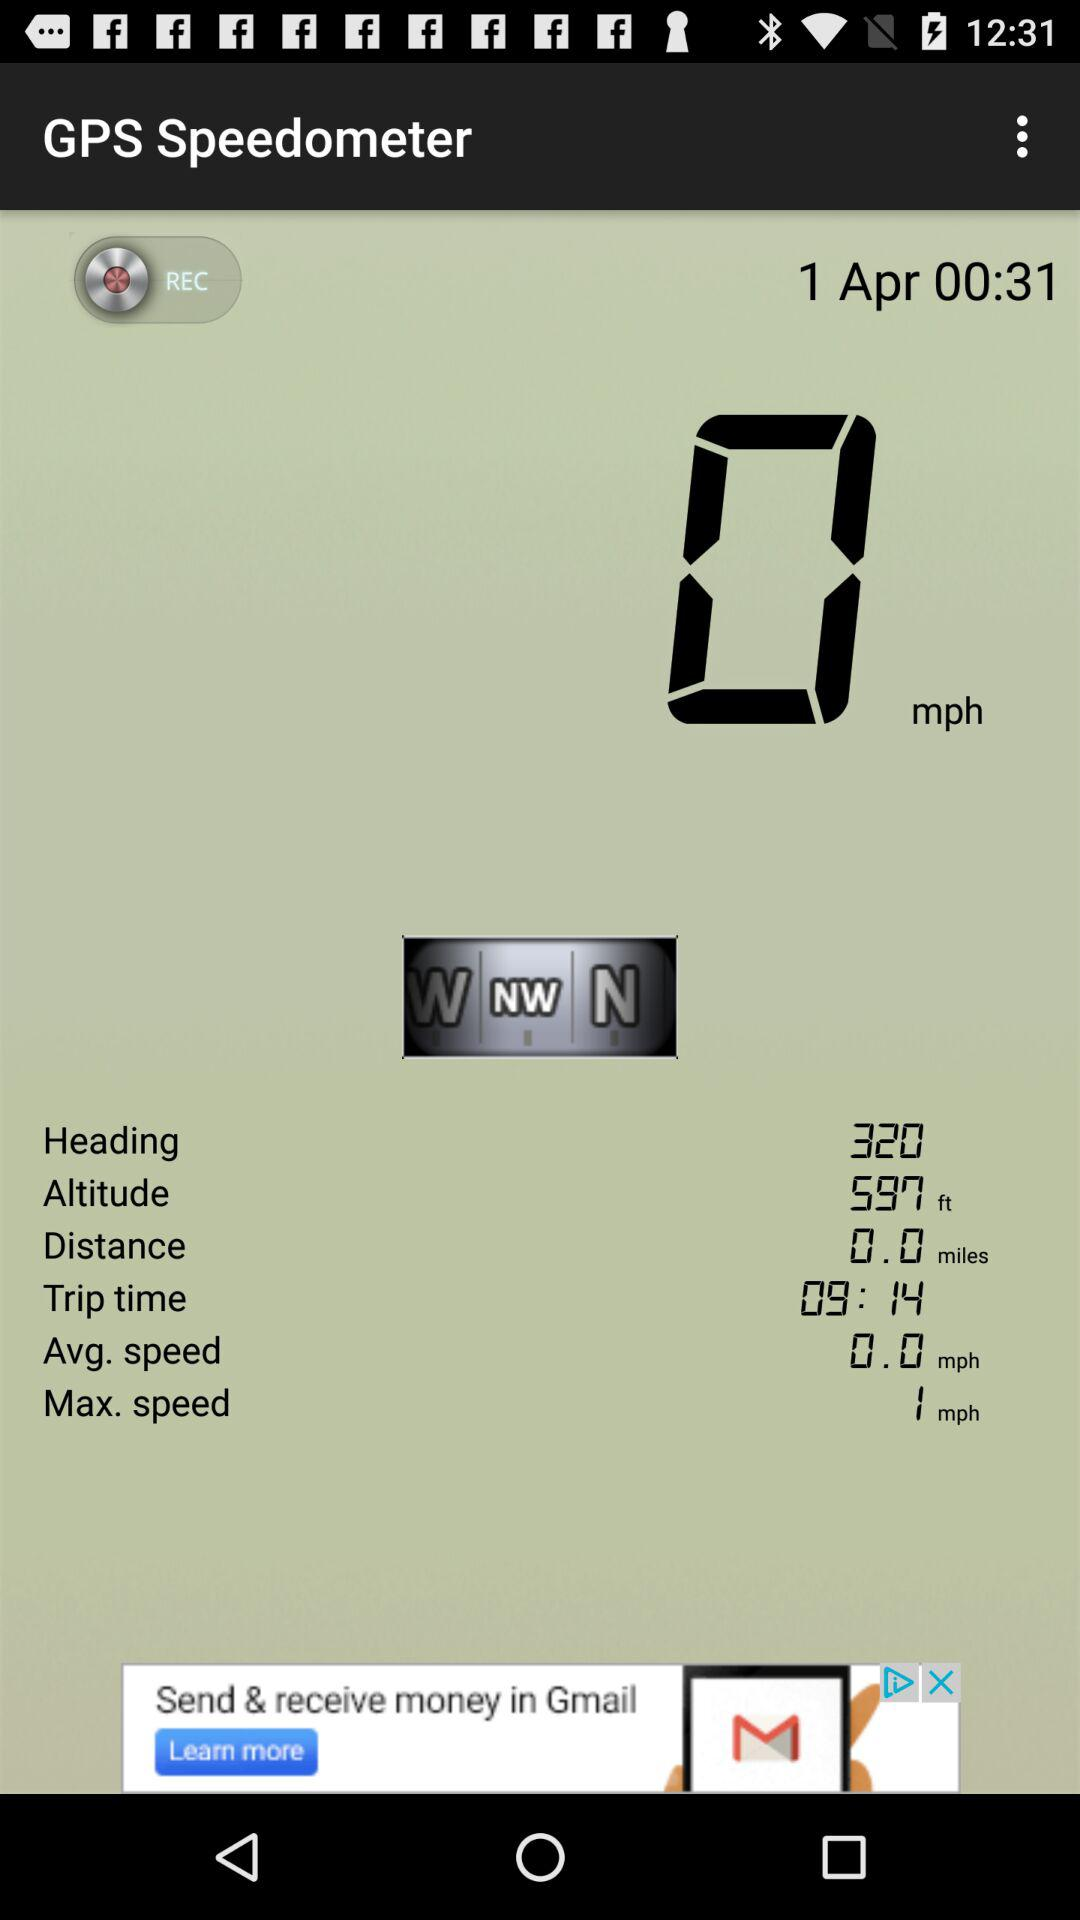What is the application name? The application name is "GPS Speedometer". 